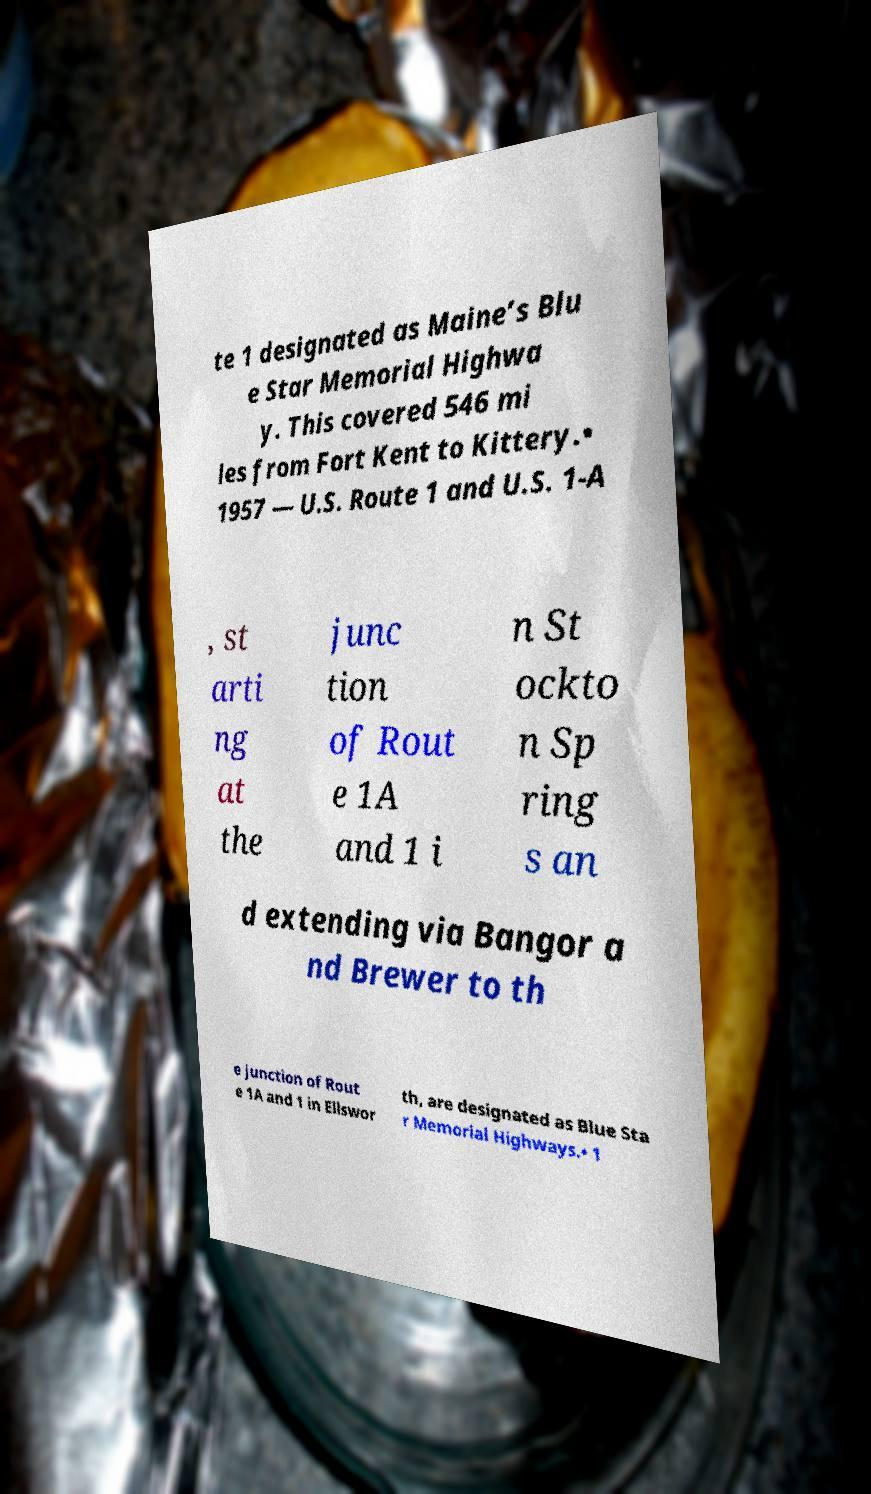Could you extract and type out the text from this image? te 1 designated as Maine’s Blu e Star Memorial Highwa y. This covered 546 mi les from Fort Kent to Kittery.• 1957 — U.S. Route 1 and U.S. 1-A , st arti ng at the junc tion of Rout e 1A and 1 i n St ockto n Sp ring s an d extending via Bangor a nd Brewer to th e junction of Rout e 1A and 1 in Ellswor th, are designated as Blue Sta r Memorial Highways.• 1 